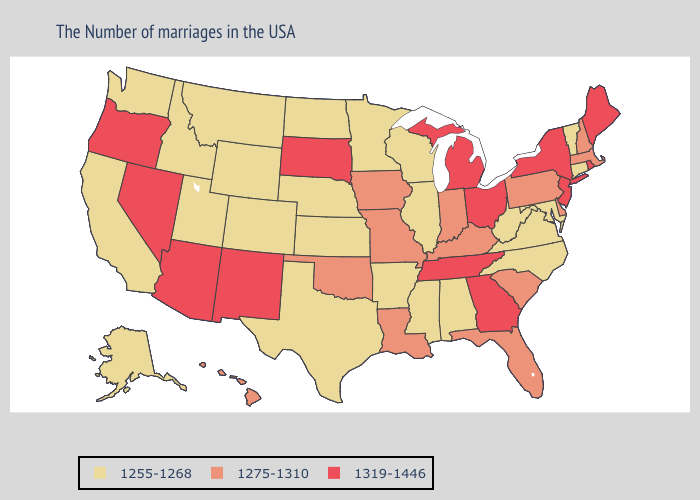Does Massachusetts have a lower value than Utah?
Keep it brief. No. Does Wyoming have a lower value than Kansas?
Answer briefly. No. Name the states that have a value in the range 1275-1310?
Be succinct. Massachusetts, New Hampshire, Delaware, Pennsylvania, South Carolina, Florida, Kentucky, Indiana, Louisiana, Missouri, Iowa, Oklahoma, Hawaii. Which states have the highest value in the USA?
Give a very brief answer. Maine, Rhode Island, New York, New Jersey, Ohio, Georgia, Michigan, Tennessee, South Dakota, New Mexico, Arizona, Nevada, Oregon. Which states have the highest value in the USA?
Give a very brief answer. Maine, Rhode Island, New York, New Jersey, Ohio, Georgia, Michigan, Tennessee, South Dakota, New Mexico, Arizona, Nevada, Oregon. Does Idaho have a higher value than Arizona?
Concise answer only. No. What is the value of New Jersey?
Give a very brief answer. 1319-1446. Which states have the lowest value in the Northeast?
Give a very brief answer. Vermont, Connecticut. Name the states that have a value in the range 1255-1268?
Quick response, please. Vermont, Connecticut, Maryland, Virginia, North Carolina, West Virginia, Alabama, Wisconsin, Illinois, Mississippi, Arkansas, Minnesota, Kansas, Nebraska, Texas, North Dakota, Wyoming, Colorado, Utah, Montana, Idaho, California, Washington, Alaska. Name the states that have a value in the range 1275-1310?
Keep it brief. Massachusetts, New Hampshire, Delaware, Pennsylvania, South Carolina, Florida, Kentucky, Indiana, Louisiana, Missouri, Iowa, Oklahoma, Hawaii. What is the value of Kansas?
Give a very brief answer. 1255-1268. What is the highest value in the USA?
Be succinct. 1319-1446. What is the highest value in the USA?
Be succinct. 1319-1446. 